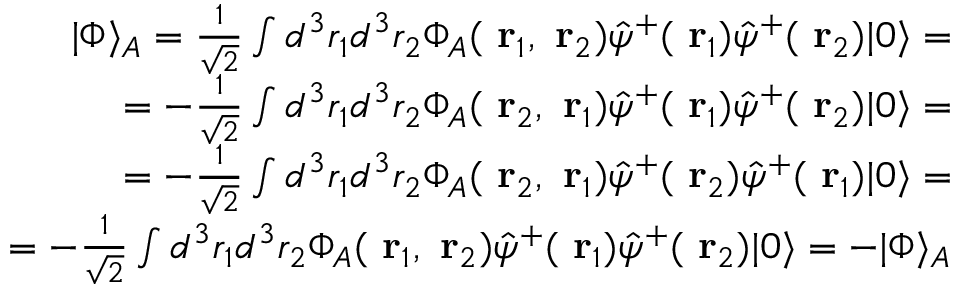Convert formula to latex. <formula><loc_0><loc_0><loc_500><loc_500>\begin{array} { r } { | \Phi \rangle _ { A } = \frac { 1 } { \sqrt { 2 } } \int d ^ { 3 } r _ { 1 } d ^ { 3 } r _ { 2 } \Phi _ { A } ( r _ { 1 } , r _ { 2 } ) \hat { \psi } ^ { + } ( r _ { 1 } ) \hat { \psi } ^ { + } ( r _ { 2 } ) | 0 \rangle = } \\ { = - \frac { 1 } { \sqrt { 2 } } \int d ^ { 3 } r _ { 1 } d ^ { 3 } r _ { 2 } \Phi _ { A } ( r _ { 2 } , r _ { 1 } ) \hat { \psi } ^ { + } ( r _ { 1 } ) \hat { \psi } ^ { + } ( r _ { 2 } ) | 0 \rangle = } \\ { = - \frac { 1 } { \sqrt { 2 } } \int d ^ { 3 } r _ { 1 } d ^ { 3 } r _ { 2 } \Phi _ { A } ( r _ { 2 } , r _ { 1 } ) \hat { \psi } ^ { + } ( r _ { 2 } ) \hat { \psi } ^ { + } ( r _ { 1 } ) | 0 \rangle = } \\ { = - \frac { 1 } { \sqrt { 2 } } \int d ^ { 3 } r _ { 1 } d ^ { 3 } r _ { 2 } \Phi _ { A } ( r _ { 1 } , r _ { 2 } ) \hat { \psi } ^ { + } ( r _ { 1 } ) \hat { \psi } ^ { + } ( r _ { 2 } ) | 0 \rangle = - | \Phi \rangle _ { A } } \end{array}</formula> 